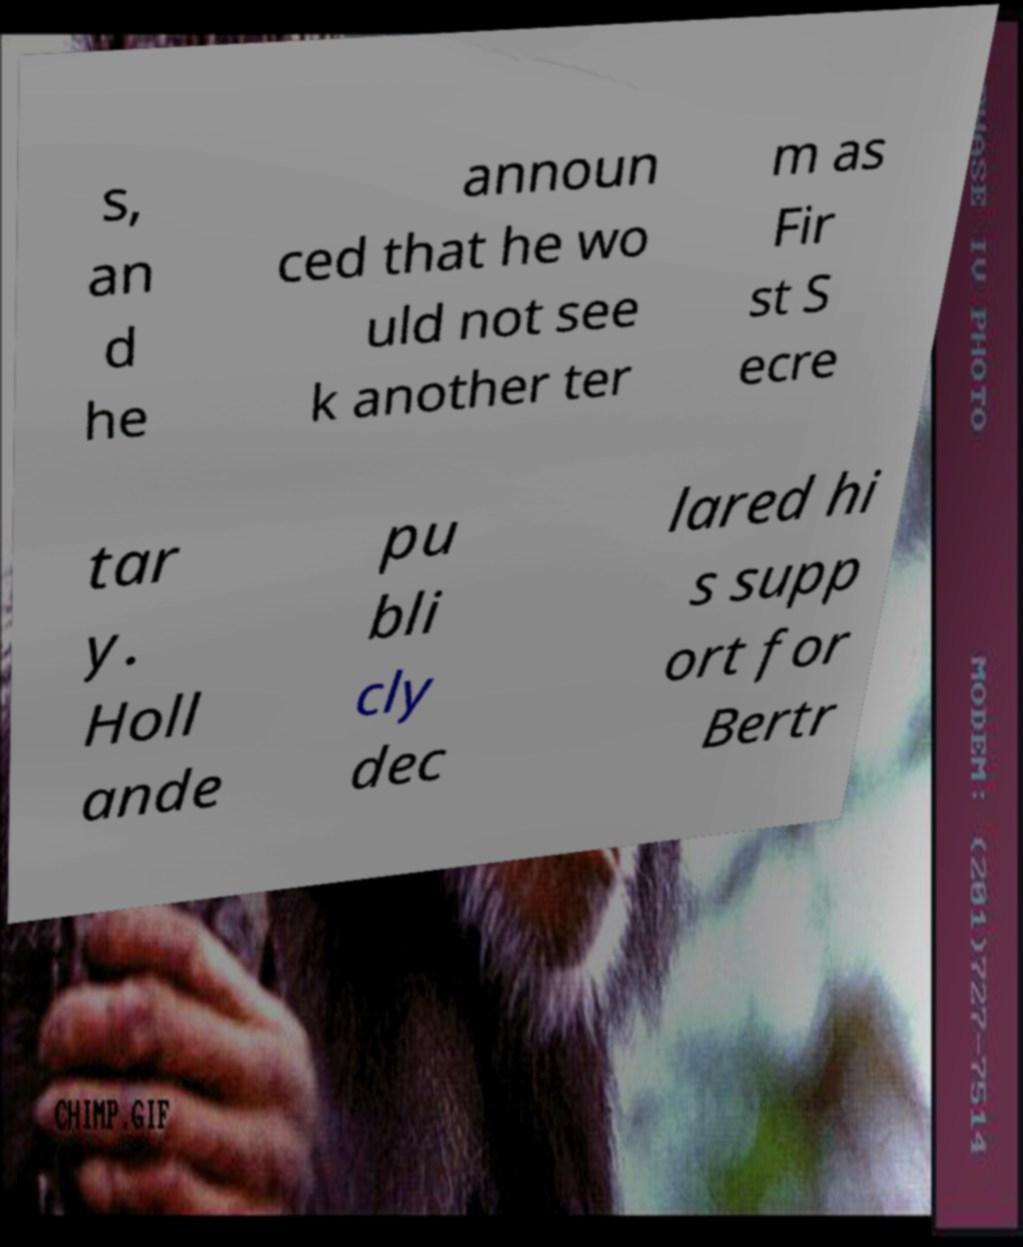Can you read and provide the text displayed in the image?This photo seems to have some interesting text. Can you extract and type it out for me? s, an d he announ ced that he wo uld not see k another ter m as Fir st S ecre tar y. Holl ande pu bli cly dec lared hi s supp ort for Bertr 